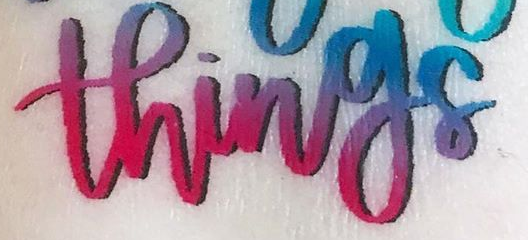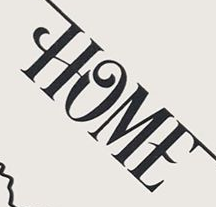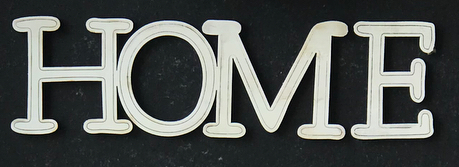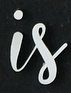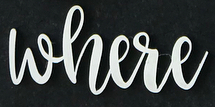Read the text content from these images in order, separated by a semicolon. things; HOME; HOME; is; where 